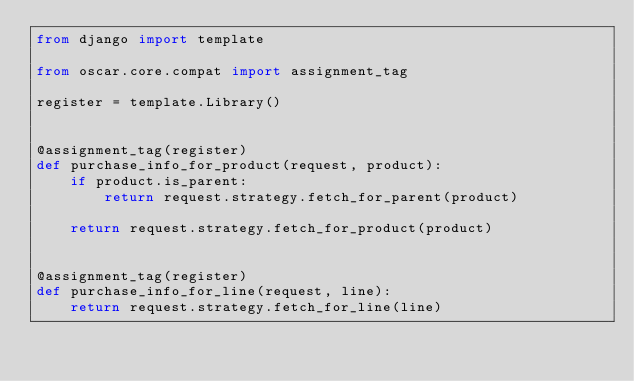Convert code to text. <code><loc_0><loc_0><loc_500><loc_500><_Python_>from django import template

from oscar.core.compat import assignment_tag

register = template.Library()


@assignment_tag(register)
def purchase_info_for_product(request, product):
    if product.is_parent:
        return request.strategy.fetch_for_parent(product)

    return request.strategy.fetch_for_product(product)


@assignment_tag(register)
def purchase_info_for_line(request, line):
    return request.strategy.fetch_for_line(line)
</code> 